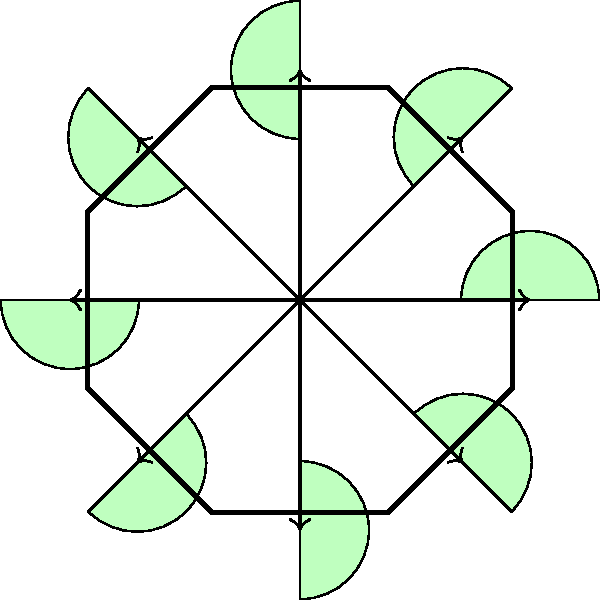Consider the geometric pattern inspired by a traditional Hawaiian quilt shown above, which forms a regular octagon. This pattern represents a dihedral group $D_8$. How many elements are in the subgroup generated by a 45-degree rotation of this pattern? To determine the number of elements in the subgroup generated by a 45-degree rotation, we can follow these steps:

1. Recall that the dihedral group $D_8$ has 16 elements in total: 8 rotations and 8 reflections.

2. The given operation is a 45-degree rotation, which is the smallest non-identity rotation in $D_8$.

3. Let's call this 45-degree rotation $r$. We need to find how many unique elements are generated by repeatedly applying $r$.

4. The elements generated by $r$ are:
   - $r^1$: 45-degree rotation
   - $r^2$: 90-degree rotation
   - $r^3$: 135-degree rotation
   - $r^4$: 180-degree rotation
   - $r^5$: 225-degree rotation
   - $r^6$: 270-degree rotation
   - $r^7$: 315-degree rotation
   - $r^8$: 360-degree rotation (which is equivalent to the identity)

5. We can see that $r^8 = e$ (the identity element), and all powers of $r$ from 1 to 7 produce unique rotations.

6. Therefore, the subgroup generated by $r$ includes the identity element and 7 unique rotations.

Thus, the subgroup has 8 elements in total.
Answer: 8 